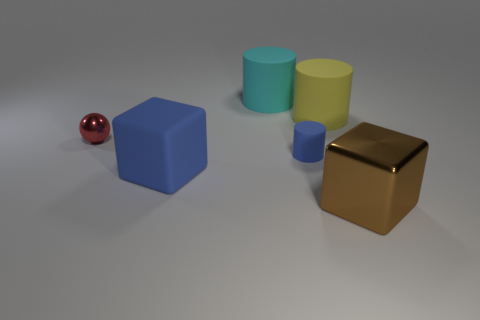Subtract all large rubber cylinders. How many cylinders are left? 1 Subtract 1 cylinders. How many cylinders are left? 2 Subtract all cubes. How many objects are left? 4 Add 2 yellow matte cylinders. How many objects exist? 8 Subtract 0 cyan cubes. How many objects are left? 6 Subtract all gray balls. Subtract all blue blocks. How many balls are left? 1 Subtract all blue cylinders. Subtract all blue cylinders. How many objects are left? 4 Add 4 large yellow cylinders. How many large yellow cylinders are left? 5 Add 3 metal balls. How many metal balls exist? 4 